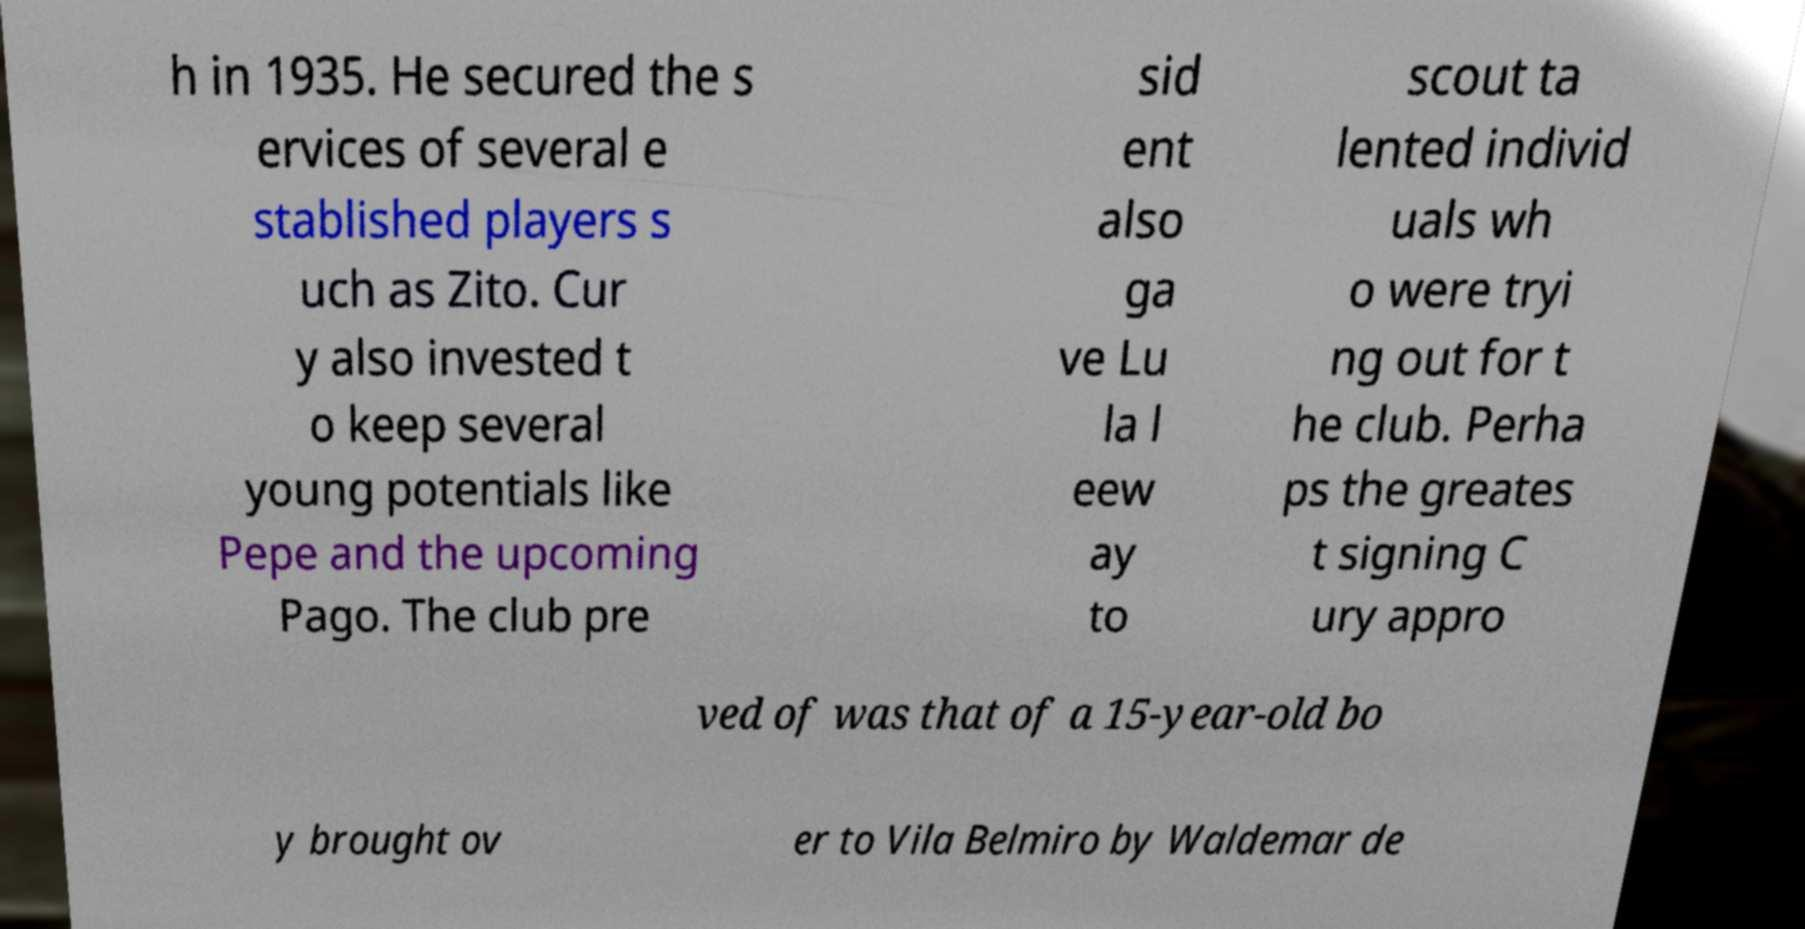Could you assist in decoding the text presented in this image and type it out clearly? h in 1935. He secured the s ervices of several e stablished players s uch as Zito. Cur y also invested t o keep several young potentials like Pepe and the upcoming Pago. The club pre sid ent also ga ve Lu la l eew ay to scout ta lented individ uals wh o were tryi ng out for t he club. Perha ps the greates t signing C ury appro ved of was that of a 15-year-old bo y brought ov er to Vila Belmiro by Waldemar de 